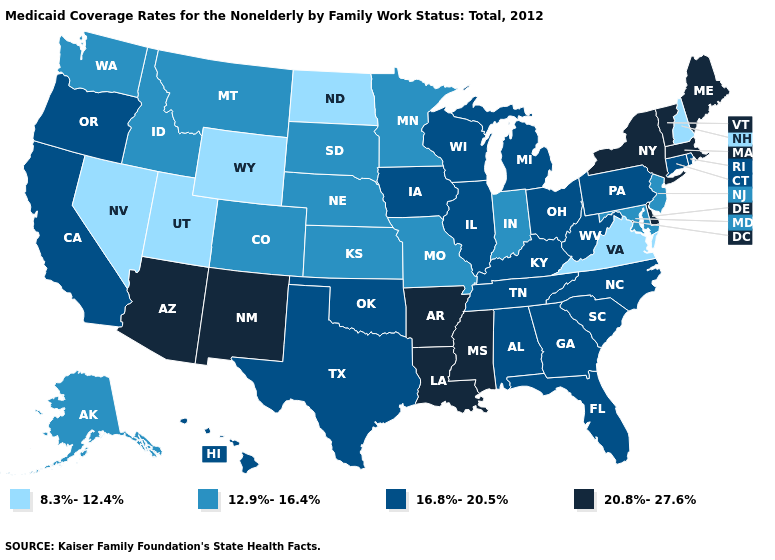What is the lowest value in the Northeast?
Concise answer only. 8.3%-12.4%. What is the lowest value in the Northeast?
Be succinct. 8.3%-12.4%. What is the lowest value in the USA?
Concise answer only. 8.3%-12.4%. Which states have the highest value in the USA?
Quick response, please. Arizona, Arkansas, Delaware, Louisiana, Maine, Massachusetts, Mississippi, New Mexico, New York, Vermont. What is the value of New Jersey?
Write a very short answer. 12.9%-16.4%. Name the states that have a value in the range 12.9%-16.4%?
Be succinct. Alaska, Colorado, Idaho, Indiana, Kansas, Maryland, Minnesota, Missouri, Montana, Nebraska, New Jersey, South Dakota, Washington. What is the value of Nebraska?
Keep it brief. 12.9%-16.4%. What is the value of West Virginia?
Answer briefly. 16.8%-20.5%. What is the lowest value in the USA?
Write a very short answer. 8.3%-12.4%. Does Georgia have the same value as New Jersey?
Concise answer only. No. What is the highest value in states that border Utah?
Short answer required. 20.8%-27.6%. What is the lowest value in the Northeast?
Be succinct. 8.3%-12.4%. Does Ohio have the same value as Nevada?
Short answer required. No. Does the first symbol in the legend represent the smallest category?
Give a very brief answer. Yes. Among the states that border Arizona , which have the highest value?
Keep it brief. New Mexico. 